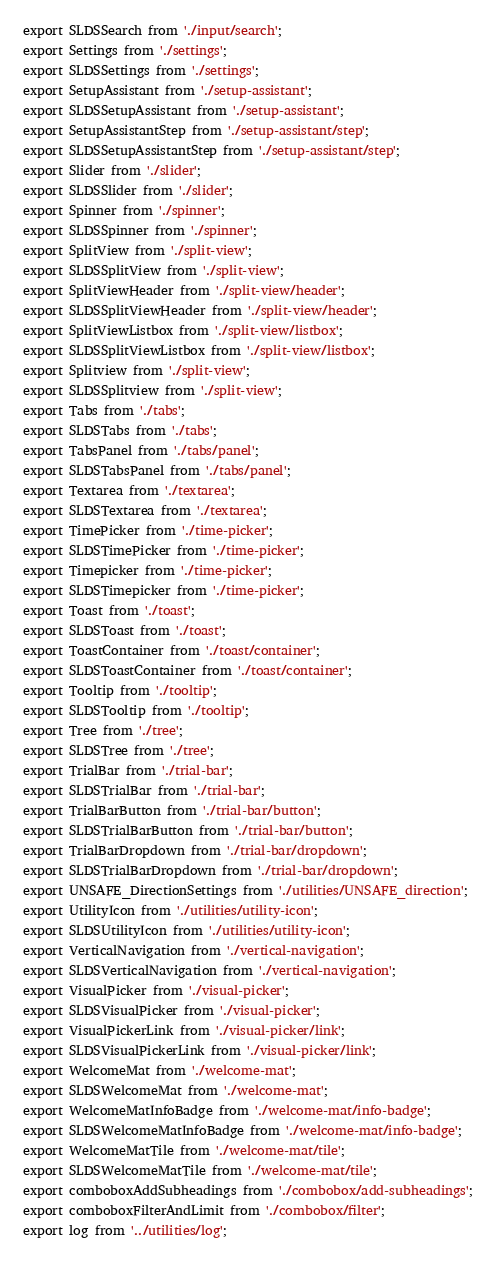<code> <loc_0><loc_0><loc_500><loc_500><_JavaScript_>export SLDSSearch from './input/search';
export Settings from './settings';
export SLDSSettings from './settings';
export SetupAssistant from './setup-assistant';
export SLDSSetupAssistant from './setup-assistant';
export SetupAssistantStep from './setup-assistant/step';
export SLDSSetupAssistantStep from './setup-assistant/step';
export Slider from './slider';
export SLDSSlider from './slider';
export Spinner from './spinner';
export SLDSSpinner from './spinner';
export SplitView from './split-view';
export SLDSSplitView from './split-view';
export SplitViewHeader from './split-view/header';
export SLDSSplitViewHeader from './split-view/header';
export SplitViewListbox from './split-view/listbox';
export SLDSSplitViewListbox from './split-view/listbox';
export Splitview from './split-view';
export SLDSSplitview from './split-view';
export Tabs from './tabs';
export SLDSTabs from './tabs';
export TabsPanel from './tabs/panel';
export SLDSTabsPanel from './tabs/panel';
export Textarea from './textarea';
export SLDSTextarea from './textarea';
export TimePicker from './time-picker';
export SLDSTimePicker from './time-picker';
export Timepicker from './time-picker';
export SLDSTimepicker from './time-picker';
export Toast from './toast';
export SLDSToast from './toast';
export ToastContainer from './toast/container';
export SLDSToastContainer from './toast/container';
export Tooltip from './tooltip';
export SLDSTooltip from './tooltip';
export Tree from './tree';
export SLDSTree from './tree';
export TrialBar from './trial-bar';
export SLDSTrialBar from './trial-bar';
export TrialBarButton from './trial-bar/button';
export SLDSTrialBarButton from './trial-bar/button';
export TrialBarDropdown from './trial-bar/dropdown';
export SLDSTrialBarDropdown from './trial-bar/dropdown';
export UNSAFE_DirectionSettings from './utilities/UNSAFE_direction';
export UtilityIcon from './utilities/utility-icon';
export SLDSUtilityIcon from './utilities/utility-icon';
export VerticalNavigation from './vertical-navigation';
export SLDSVerticalNavigation from './vertical-navigation';
export VisualPicker from './visual-picker';
export SLDSVisualPicker from './visual-picker';
export VisualPickerLink from './visual-picker/link';
export SLDSVisualPickerLink from './visual-picker/link';
export WelcomeMat from './welcome-mat';
export SLDSWelcomeMat from './welcome-mat';
export WelcomeMatInfoBadge from './welcome-mat/info-badge';
export SLDSWelcomeMatInfoBadge from './welcome-mat/info-badge';
export WelcomeMatTile from './welcome-mat/tile';
export SLDSWelcomeMatTile from './welcome-mat/tile';
export comboboxAddSubheadings from './combobox/add-subheadings';
export comboboxFilterAndLimit from './combobox/filter';
export log from '../utilities/log';
</code> 